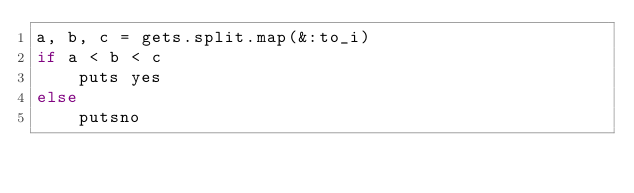<code> <loc_0><loc_0><loc_500><loc_500><_Ruby_>a, b, c = gets.split.map(&:to_i)
if a < b < c
    puts yes
else
    putsno</code> 